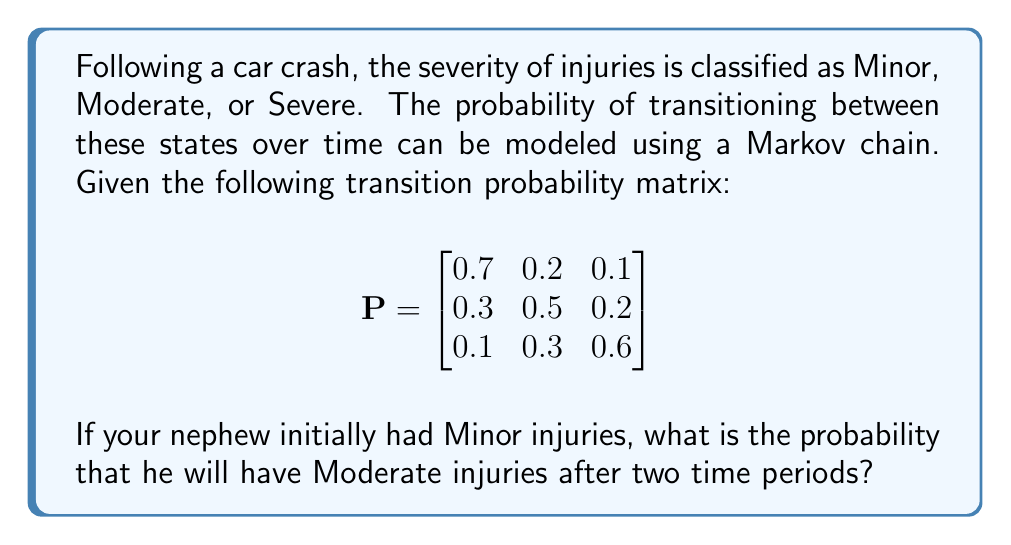Help me with this question. To solve this problem, we need to use the Chapman-Kolmogorov equations and matrix multiplication. Let's break it down step-by-step:

1) The initial state vector for Minor injuries is:
   $$v_0 = \begin{bmatrix} 1 & 0 & 0 \end{bmatrix}$$

2) To find the probabilities after two time periods, we need to multiply the initial state vector by the transition matrix twice:
   $$v_2 = v_0 \cdot P^2$$

3) First, let's calculate $P^2$:
   $$P^2 = P \cdot P = \begin{bmatrix}
   0.7 & 0.2 & 0.1 \\
   0.3 & 0.5 & 0.2 \\
   0.1 & 0.3 & 0.6
   \end{bmatrix} \cdot 
   \begin{bmatrix}
   0.7 & 0.2 & 0.1 \\
   0.3 & 0.5 & 0.2 \\
   0.1 & 0.3 & 0.6
   \end{bmatrix}$$

4) Performing the matrix multiplication:
   $$P^2 = \begin{bmatrix}
   0.56 & 0.27 & 0.17 \\
   0.37 & 0.41 & 0.22 \\
   0.22 & 0.36 & 0.42
   \end{bmatrix}$$

5) Now, we multiply the initial state vector by $P^2$:
   $$v_2 = \begin{bmatrix} 1 & 0 & 0 \end{bmatrix} \cdot 
   \begin{bmatrix}
   0.56 & 0.27 & 0.17 \\
   0.37 & 0.41 & 0.22 \\
   0.22 & 0.36 & 0.42
   \end{bmatrix}$$

6) This results in:
   $$v_2 = \begin{bmatrix} 0.56 & 0.27 & 0.17 \end{bmatrix}$$

7) The probability of having Moderate injuries after two time periods is the second element of this vector, which is 0.27 or 27%.
Answer: 0.27 